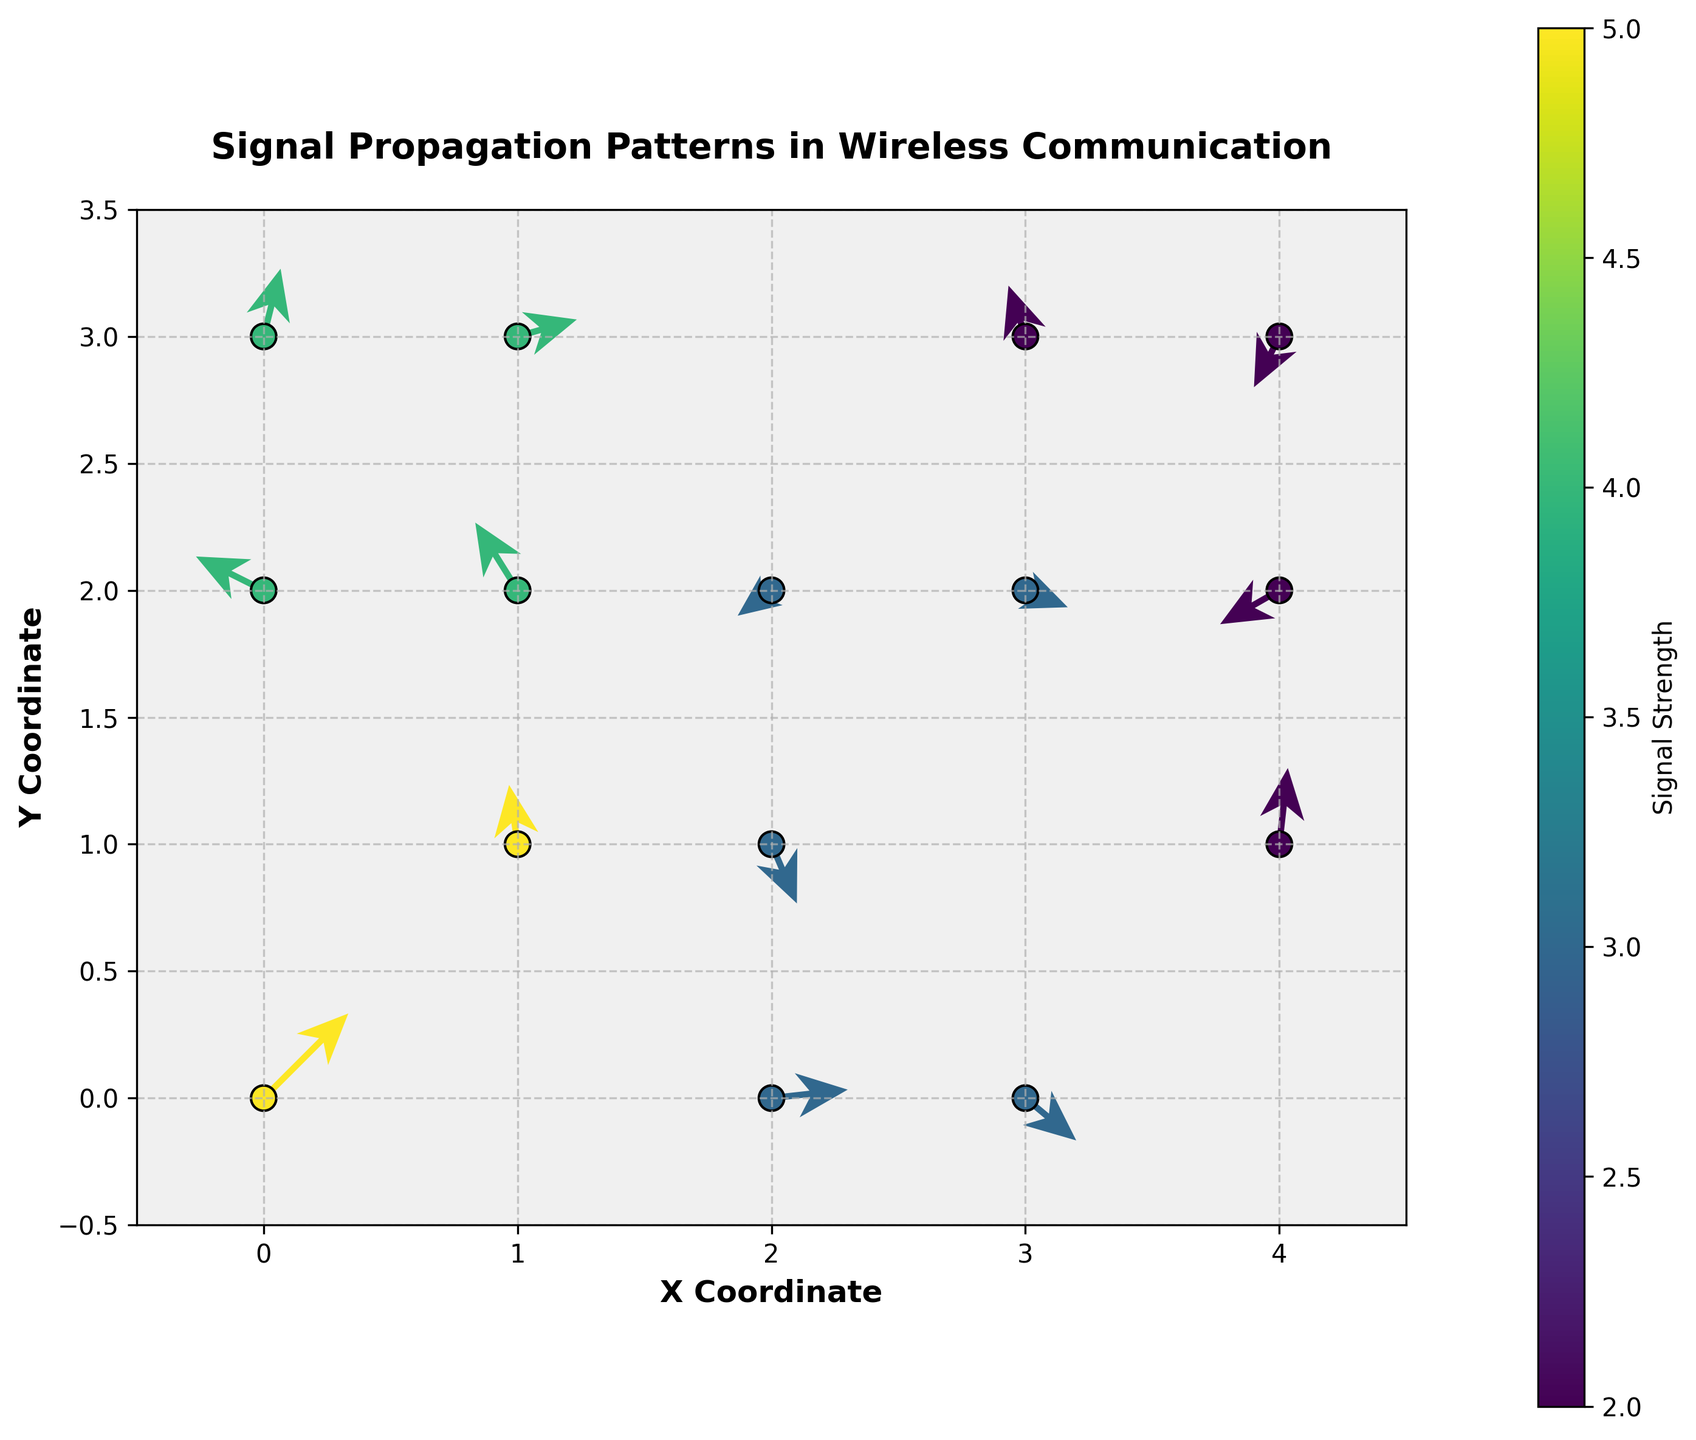What is the title of the figure? The title is usually located at the top center of the figure. It provides a concise summary of what is being visualized. In this case, it reads: "Signal Propagation Patterns in Wireless Communication".
Answer: Signal Propagation Patterns in Wireless Communication How many data points are presented in the figure? By counting the individual locations (coordinate pairs) where vectors originate, we can determine the number of data points. There are 15 such origins.
Answer: 15 Which coordinate has the highest signal strength? By looking at the color coding and matching it against the color bar legend, the darkest points represent the highest strength. The coordinate (0, 0) has the darkest shade indicating a strength of 5.
Answer: (0, 0) What is the direction of the vector at coordinate (1, 2)? Examining the vector originating from (1, 2), we see it has an arrow pointing leftwards and upwards, corresponding to components (-0.5, 0.8).
Answer: Leftwards and upwards Which coordinate shows a nearly horizontal vector with low strength? Identifying coordinates with almost horizontal vectors involves looking for vectors with small vertical components. The coordinate (3, 2) has a vector of (0.5, -0.2) which is almost horizontal and its strength is 3 (intermediate based on the color bar).
Answer: (3, 2) Which vectors indicate a negative linear combination of their components? A vector indicating a negative direction in combined x and y planes has both components negative. Vectors at coordinates (2, 2) and (4, 3) show this behavior with components (-0.4, -0.3) and (-0.3, -0.6) respectively.
Answer: (2, 2) and (4, 3) What patterns can we infer about signal propagation directions on the plot? Analyze all vectors to understand general trends. Across coordinates, there's a mix of vectors pointing in various directions, indicating non-uniform signal propagation affected by surroundings, obstacles, or other network characteristics, as vectors change direction and strength across coordinates.
Answer: Non-uniform signal propagation in various directions Which coordinate has the largest y-component? By examining the magnitudinal vectors, the largest y-component is found at coordinate (4, 1) with a component value of 0.9.
Answer: (4, 1) What is the average signal strength across all data points? Strength values are 5, 4, 3, 2, 4, 3, 2, 3, 4, 2, 3, 5, 3, 4, 2. To find the average: (5+4+3+2+4+3+2+3+4+2+3+5+3+4+2) / 15 = 3.27.
Answer: 3.27 